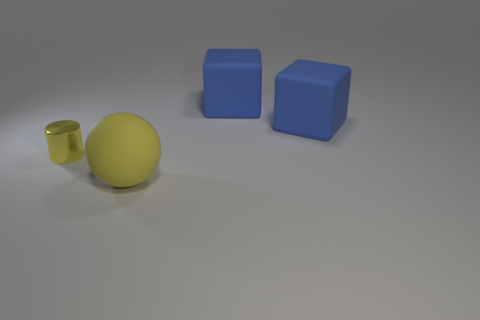Add 4 tiny green objects. How many objects exist? 8 Subtract all spheres. How many objects are left? 3 Add 1 small yellow metallic cylinders. How many small yellow metallic cylinders exist? 2 Subtract 0 cyan cubes. How many objects are left? 4 Subtract all cylinders. Subtract all big blue rubber cubes. How many objects are left? 1 Add 3 yellow shiny cylinders. How many yellow shiny cylinders are left? 4 